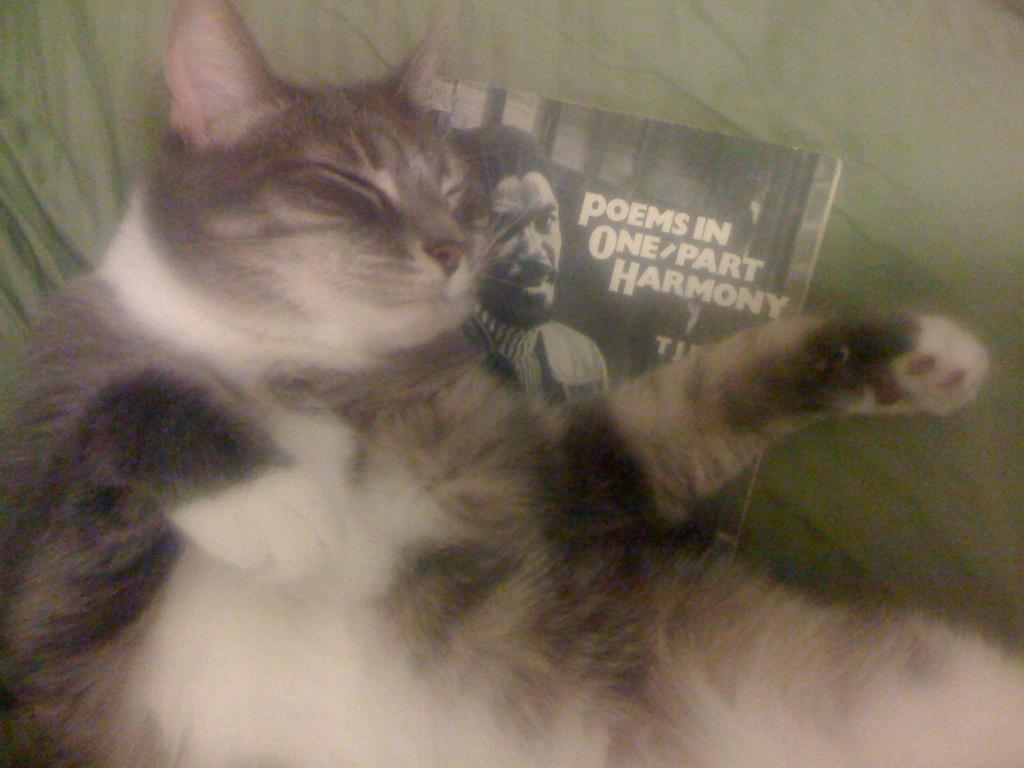What animal can be seen in the image? There is a cat in the image. What is the cat lying on? The cat is lying on a book. What is depicted on the book? There is a photo of a person on the book. What else can be found on the book? There is text on the book. What is the book placed on? The book is placed on a cloth. What type of bottle is being used to water the cherry tree in the image? There is no bottle or cherry tree present in the image; it features a cat lying on a book with a photo of a person and text. 